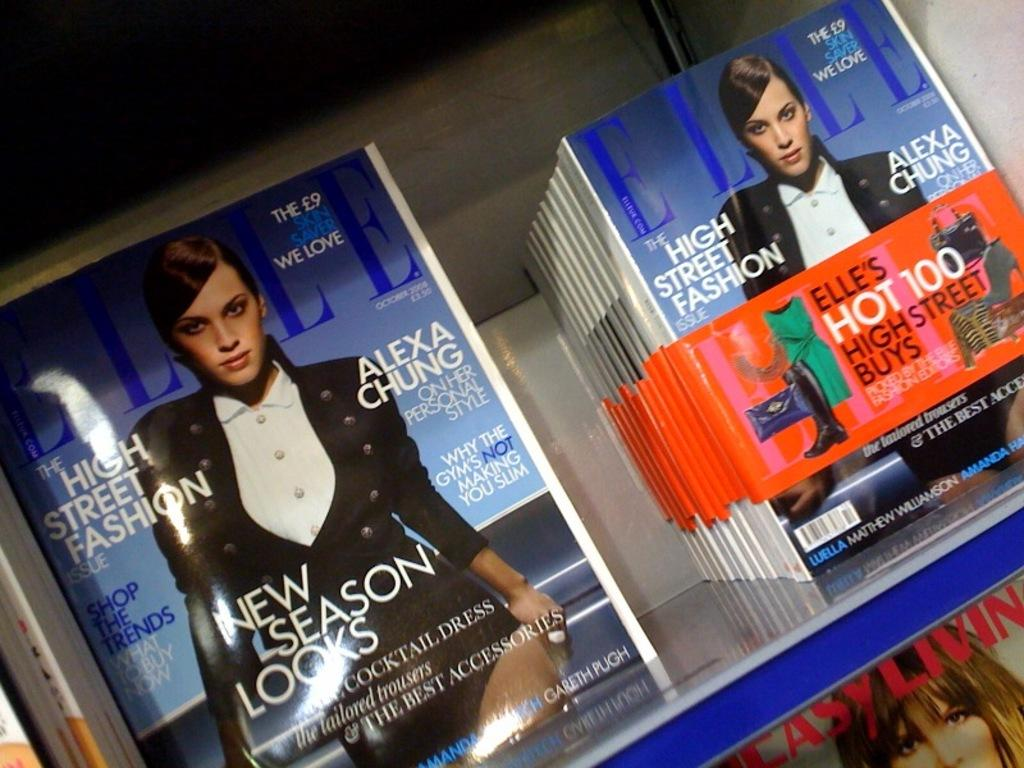<image>
Offer a succinct explanation of the picture presented. a magazine stacked by another one for new season looks 